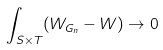<formula> <loc_0><loc_0><loc_500><loc_500>\int _ { S \times T } ( W _ { G _ { n } } - W ) \to 0</formula> 